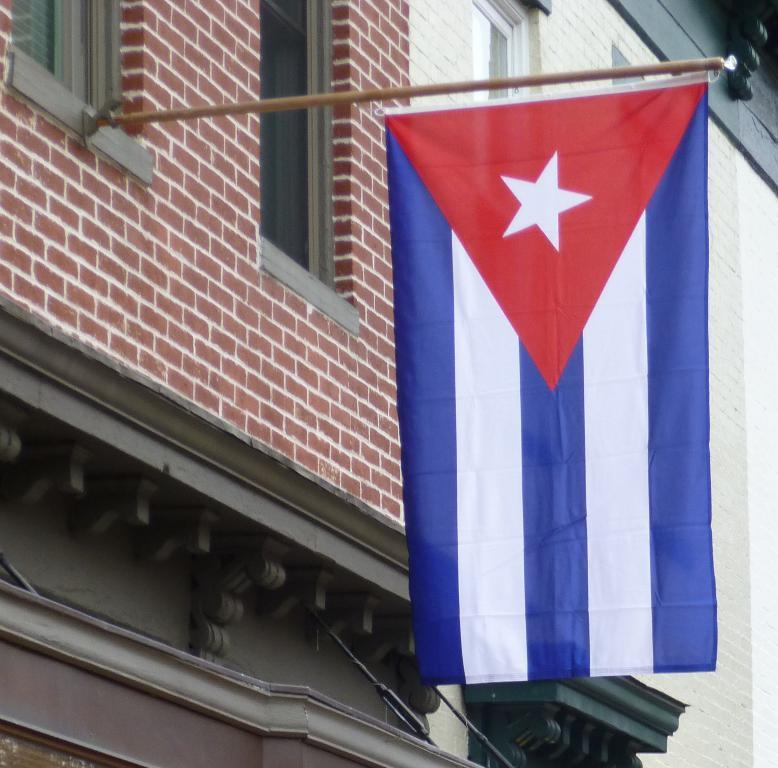What type of structure is present in the image? There is a building in the image. What is attached to the flag post in the image? There is a flag on a flag post in the image. What feature of the building can be seen in the image? There are windows visible in the image. What type of food is the cook preparing in the image? There is no cook or food preparation visible in the image. How many people are running in the image? There is no running or people visible in the image. 